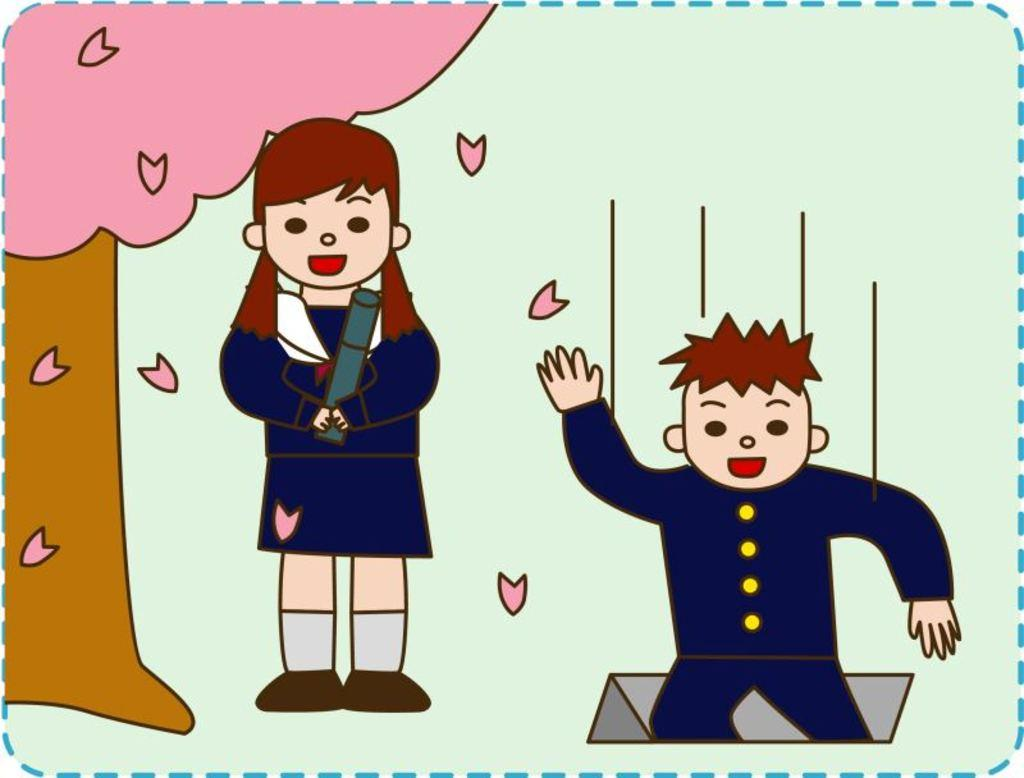What is the main subject of the art piece in the image? The art piece depicts a girl and a boy. What other elements are included in the art piece? The art piece includes a tree. What is the color of the background in the art piece? The background of the art piece is green in color. What type of oil is being used to create the circle around the girl's lip in the image? There is no oil, circle, or lip present in the image; it features an art piece depicting a girl and a boy with a tree in a green background. 